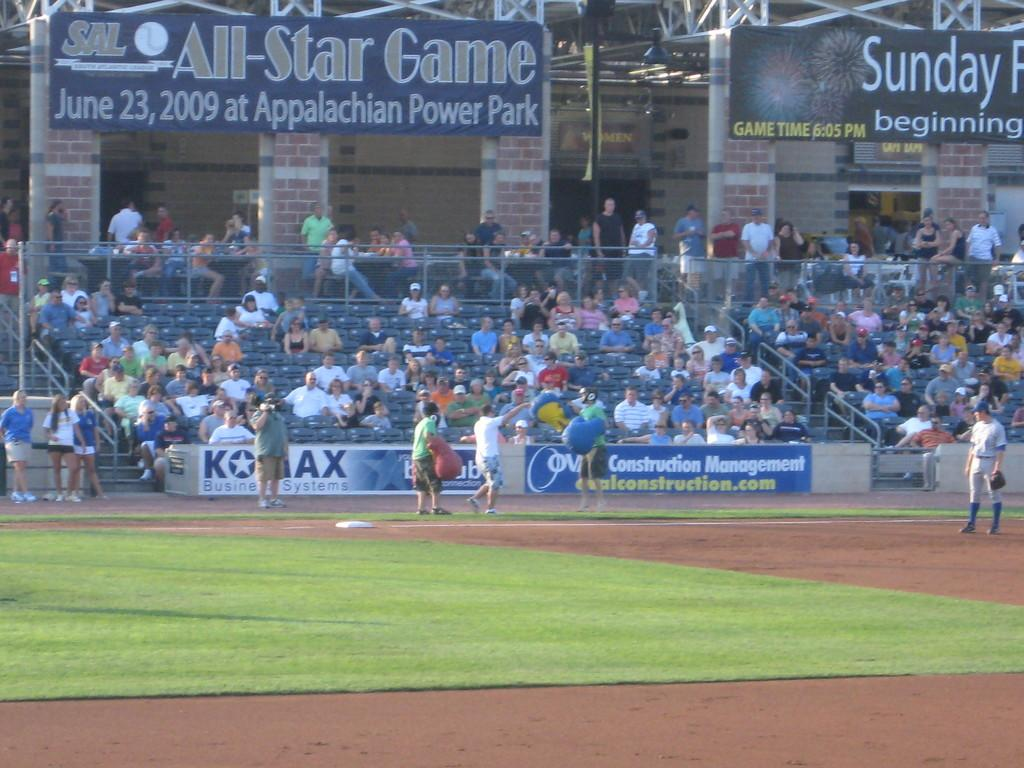<image>
Write a terse but informative summary of the picture. the all star game taking place at the appalachian power park 